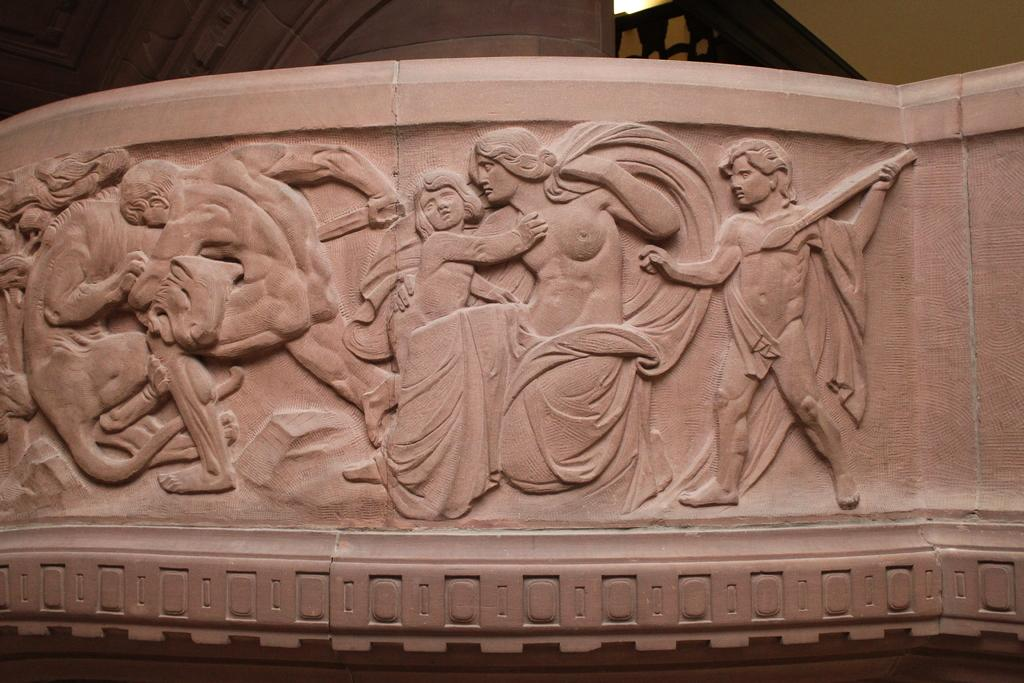What can be seen on the wall in the image? There are sculptures carved on the wall in the image. What type of artwork is depicted on the wall? The artwork on the wall consists of sculptures that have been carved into the surface. How many sculptures can be seen on the wall? The number of sculptures on the wall is not specified in the provided facts, so it cannot be determined from the image. What type of attraction is depicted in the image? There is no attraction present in the image; it only features sculptures carved on the wall. What type of drink is being served in the image? There is no drink present in the image; it only features sculptures carved on the wall. 